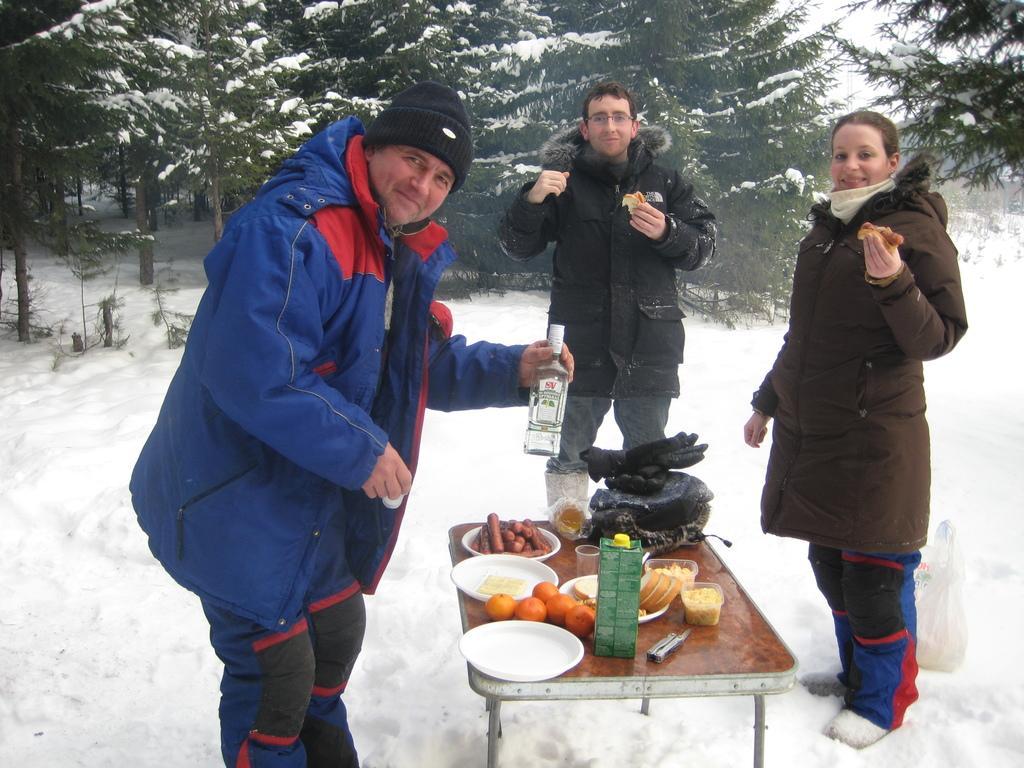Could you give a brief overview of what you see in this image? In this image I can see there are some foods on the table and there are three people standing and looking at someone and a man on the left side holding a bottle. 